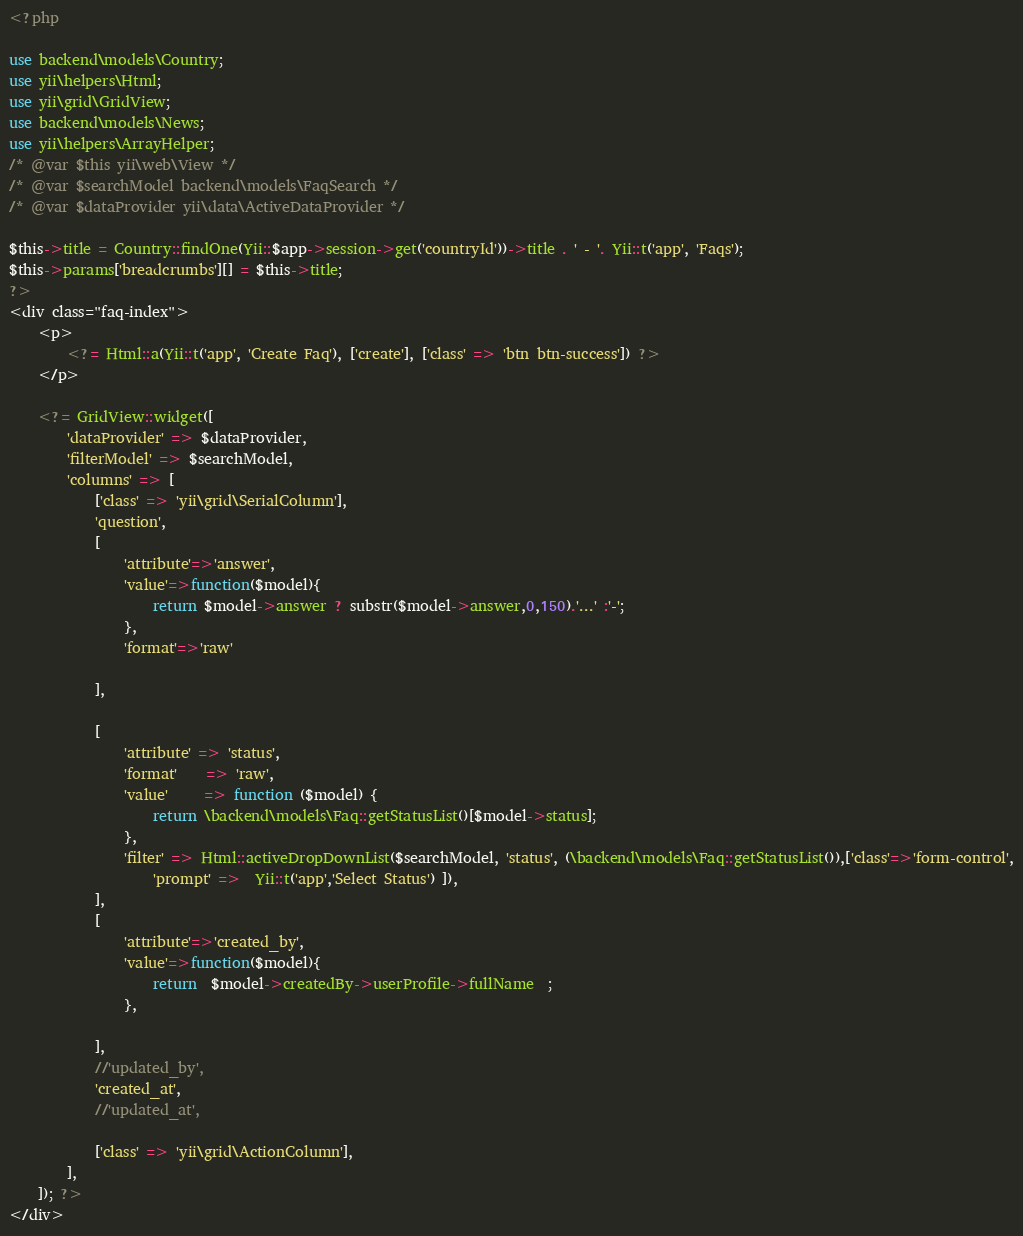Convert code to text. <code><loc_0><loc_0><loc_500><loc_500><_PHP_><?php

use backend\models\Country;
use yii\helpers\Html;
use yii\grid\GridView;
use backend\models\News;
use yii\helpers\ArrayHelper;
/* @var $this yii\web\View */
/* @var $searchModel backend\models\FaqSearch */
/* @var $dataProvider yii\data\ActiveDataProvider */

$this->title = Country::findOne(Yii::$app->session->get('countryId'))->title . ' - '. Yii::t('app', 'Faqs');
$this->params['breadcrumbs'][] = $this->title;
?>
<div class="faq-index">
    <p>
        <?= Html::a(Yii::t('app', 'Create Faq'), ['create'], ['class' => 'btn btn-success']) ?>
    </p>

    <?= GridView::widget([
        'dataProvider' => $dataProvider,
        'filterModel' => $searchModel,
        'columns' => [
            ['class' => 'yii\grid\SerialColumn'],
            'question',
            [
                'attribute'=>'answer',
                'value'=>function($model){
                    return $model->answer ? substr($model->answer,0,150).'...' :'-';
                },
                'format'=>'raw'

            ],

            [
                'attribute' => 'status',
                'format'    => 'raw',
                'value'     => function ($model) {
                    return \backend\models\Faq::getStatusList()[$model->status];
                },
                'filter' => Html::activeDropDownList($searchModel, 'status', (\backend\models\Faq::getStatusList()),['class'=>'form-control',
                    'prompt' =>  Yii::t('app','Select Status') ]),
            ],
            [
                'attribute'=>'created_by',
                'value'=>function($model){
                    return  $model->createdBy->userProfile->fullName  ;
                },

            ],
            //'updated_by',
            'created_at',
            //'updated_at',

            ['class' => 'yii\grid\ActionColumn'],
        ],
    ]); ?>
</div>
</code> 